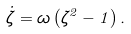<formula> <loc_0><loc_0><loc_500><loc_500>\dot { \zeta } = \omega \left ( \zeta ^ { 2 } - 1 \right ) .</formula> 